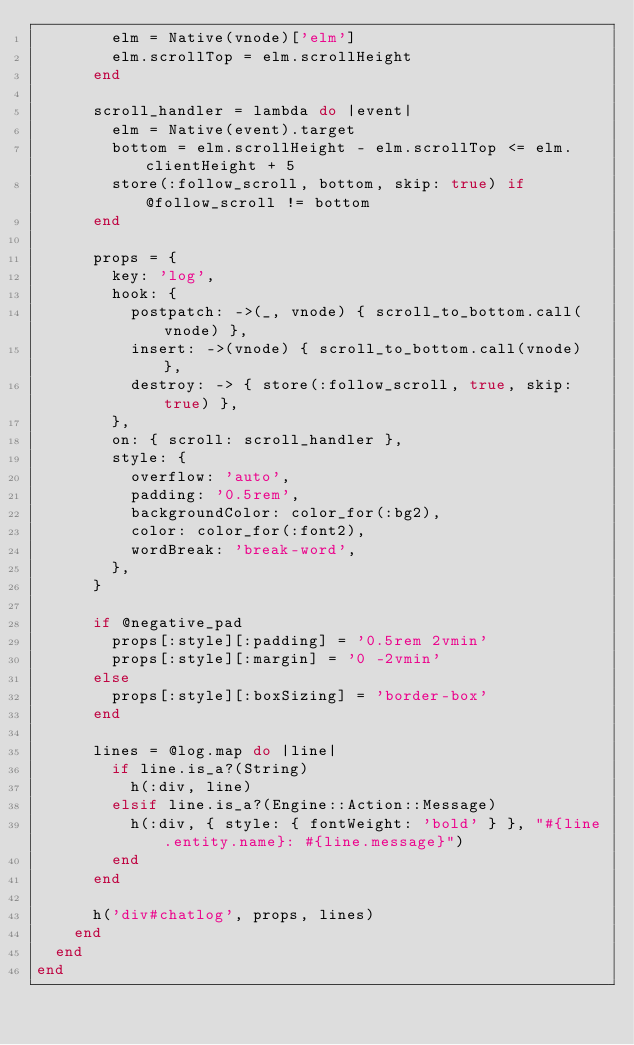<code> <loc_0><loc_0><loc_500><loc_500><_Ruby_>        elm = Native(vnode)['elm']
        elm.scrollTop = elm.scrollHeight
      end

      scroll_handler = lambda do |event|
        elm = Native(event).target
        bottom = elm.scrollHeight - elm.scrollTop <= elm.clientHeight + 5
        store(:follow_scroll, bottom, skip: true) if @follow_scroll != bottom
      end

      props = {
        key: 'log',
        hook: {
          postpatch: ->(_, vnode) { scroll_to_bottom.call(vnode) },
          insert: ->(vnode) { scroll_to_bottom.call(vnode) },
          destroy: -> { store(:follow_scroll, true, skip: true) },
        },
        on: { scroll: scroll_handler },
        style: {
          overflow: 'auto',
          padding: '0.5rem',
          backgroundColor: color_for(:bg2),
          color: color_for(:font2),
          wordBreak: 'break-word',
        },
      }

      if @negative_pad
        props[:style][:padding] = '0.5rem 2vmin'
        props[:style][:margin] = '0 -2vmin'
      else
        props[:style][:boxSizing] = 'border-box'
      end

      lines = @log.map do |line|
        if line.is_a?(String)
          h(:div, line)
        elsif line.is_a?(Engine::Action::Message)
          h(:div, { style: { fontWeight: 'bold' } }, "#{line.entity.name}: #{line.message}")
        end
      end

      h('div#chatlog', props, lines)
    end
  end
end
</code> 